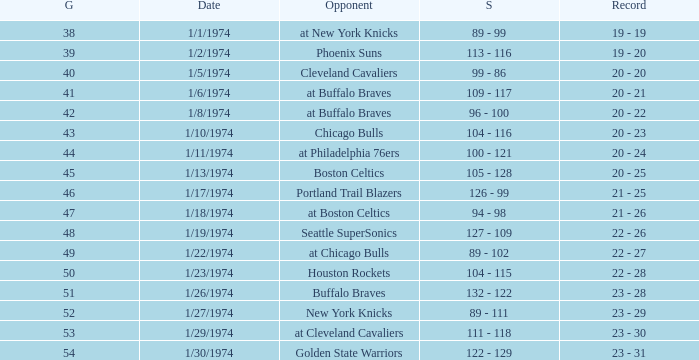What was the record after game 51 on 1/27/1974? 23 - 29. 